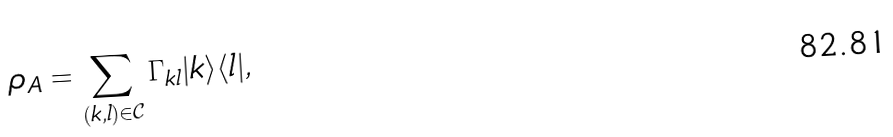<formula> <loc_0><loc_0><loc_500><loc_500>\rho _ { A } = \sum _ { ( k , l ) \in \mathcal { C } } \Gamma _ { k l } | k \rangle \langle l | ,</formula> 